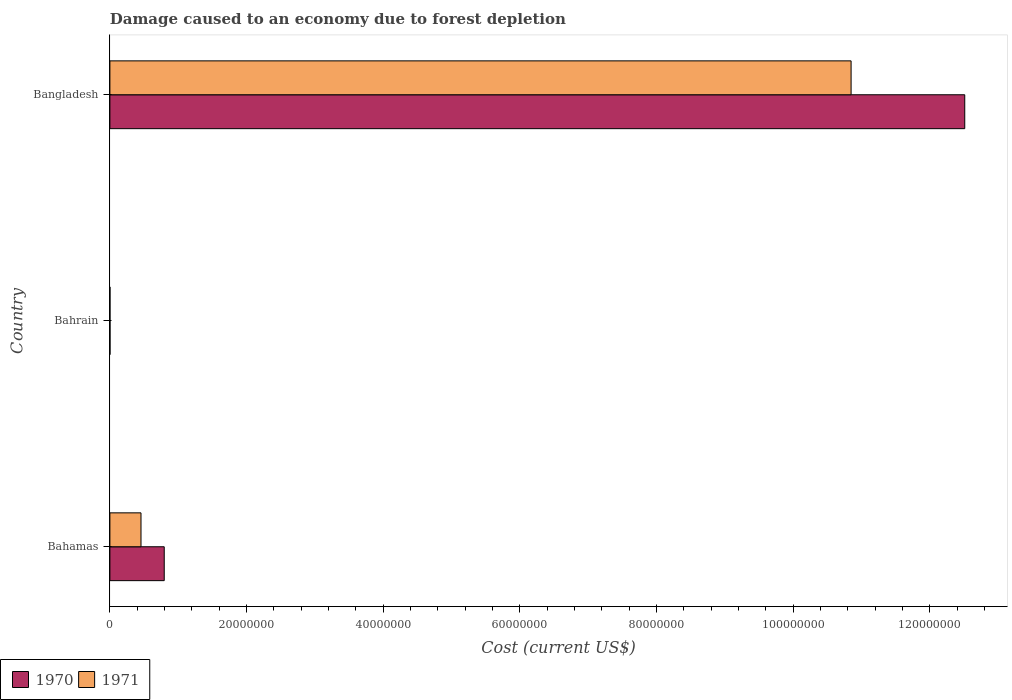What is the label of the 3rd group of bars from the top?
Make the answer very short. Bahamas. In how many cases, is the number of bars for a given country not equal to the number of legend labels?
Make the answer very short. 0. What is the cost of damage caused due to forest depletion in 1971 in Bangladesh?
Offer a very short reply. 1.08e+08. Across all countries, what is the maximum cost of damage caused due to forest depletion in 1971?
Provide a short and direct response. 1.08e+08. Across all countries, what is the minimum cost of damage caused due to forest depletion in 1971?
Offer a terse response. 1.16e+04. In which country was the cost of damage caused due to forest depletion in 1971 minimum?
Your answer should be very brief. Bahrain. What is the total cost of damage caused due to forest depletion in 1970 in the graph?
Offer a terse response. 1.33e+08. What is the difference between the cost of damage caused due to forest depletion in 1970 in Bahamas and that in Bangladesh?
Your answer should be compact. -1.17e+08. What is the difference between the cost of damage caused due to forest depletion in 1971 in Bahamas and the cost of damage caused due to forest depletion in 1970 in Bahrain?
Offer a terse response. 4.54e+06. What is the average cost of damage caused due to forest depletion in 1970 per country?
Ensure brevity in your answer.  4.44e+07. What is the difference between the cost of damage caused due to forest depletion in 1971 and cost of damage caused due to forest depletion in 1970 in Bahamas?
Your answer should be compact. -3.40e+06. What is the ratio of the cost of damage caused due to forest depletion in 1971 in Bahamas to that in Bahrain?
Make the answer very short. 391.63. Is the cost of damage caused due to forest depletion in 1970 in Bahrain less than that in Bangladesh?
Provide a succinct answer. Yes. What is the difference between the highest and the second highest cost of damage caused due to forest depletion in 1970?
Ensure brevity in your answer.  1.17e+08. What is the difference between the highest and the lowest cost of damage caused due to forest depletion in 1971?
Provide a succinct answer. 1.08e+08. In how many countries, is the cost of damage caused due to forest depletion in 1970 greater than the average cost of damage caused due to forest depletion in 1970 taken over all countries?
Your answer should be very brief. 1. How many bars are there?
Ensure brevity in your answer.  6. Does the graph contain grids?
Provide a succinct answer. No. What is the title of the graph?
Offer a terse response. Damage caused to an economy due to forest depletion. What is the label or title of the X-axis?
Your answer should be very brief. Cost (current US$). What is the Cost (current US$) of 1970 in Bahamas?
Offer a very short reply. 7.95e+06. What is the Cost (current US$) in 1971 in Bahamas?
Your answer should be very brief. 4.55e+06. What is the Cost (current US$) in 1970 in Bahrain?
Your response must be concise. 1.53e+04. What is the Cost (current US$) of 1971 in Bahrain?
Your response must be concise. 1.16e+04. What is the Cost (current US$) of 1970 in Bangladesh?
Provide a short and direct response. 1.25e+08. What is the Cost (current US$) in 1971 in Bangladesh?
Offer a very short reply. 1.08e+08. Across all countries, what is the maximum Cost (current US$) of 1970?
Offer a very short reply. 1.25e+08. Across all countries, what is the maximum Cost (current US$) in 1971?
Your answer should be very brief. 1.08e+08. Across all countries, what is the minimum Cost (current US$) in 1970?
Your response must be concise. 1.53e+04. Across all countries, what is the minimum Cost (current US$) of 1971?
Ensure brevity in your answer.  1.16e+04. What is the total Cost (current US$) in 1970 in the graph?
Provide a succinct answer. 1.33e+08. What is the total Cost (current US$) of 1971 in the graph?
Ensure brevity in your answer.  1.13e+08. What is the difference between the Cost (current US$) of 1970 in Bahamas and that in Bahrain?
Make the answer very short. 7.94e+06. What is the difference between the Cost (current US$) of 1971 in Bahamas and that in Bahrain?
Ensure brevity in your answer.  4.54e+06. What is the difference between the Cost (current US$) in 1970 in Bahamas and that in Bangladesh?
Your response must be concise. -1.17e+08. What is the difference between the Cost (current US$) in 1971 in Bahamas and that in Bangladesh?
Your answer should be very brief. -1.04e+08. What is the difference between the Cost (current US$) in 1970 in Bahrain and that in Bangladesh?
Your answer should be very brief. -1.25e+08. What is the difference between the Cost (current US$) in 1971 in Bahrain and that in Bangladesh?
Your answer should be very brief. -1.08e+08. What is the difference between the Cost (current US$) of 1970 in Bahamas and the Cost (current US$) of 1971 in Bahrain?
Keep it short and to the point. 7.94e+06. What is the difference between the Cost (current US$) of 1970 in Bahamas and the Cost (current US$) of 1971 in Bangladesh?
Your answer should be compact. -1.01e+08. What is the difference between the Cost (current US$) of 1970 in Bahrain and the Cost (current US$) of 1971 in Bangladesh?
Your answer should be compact. -1.08e+08. What is the average Cost (current US$) in 1970 per country?
Your answer should be compact. 4.44e+07. What is the average Cost (current US$) of 1971 per country?
Offer a terse response. 3.77e+07. What is the difference between the Cost (current US$) of 1970 and Cost (current US$) of 1971 in Bahamas?
Give a very brief answer. 3.40e+06. What is the difference between the Cost (current US$) of 1970 and Cost (current US$) of 1971 in Bahrain?
Make the answer very short. 3638.2. What is the difference between the Cost (current US$) in 1970 and Cost (current US$) in 1971 in Bangladesh?
Make the answer very short. 1.66e+07. What is the ratio of the Cost (current US$) of 1970 in Bahamas to that in Bahrain?
Provide a succinct answer. 520.98. What is the ratio of the Cost (current US$) in 1971 in Bahamas to that in Bahrain?
Make the answer very short. 391.63. What is the ratio of the Cost (current US$) of 1970 in Bahamas to that in Bangladesh?
Ensure brevity in your answer.  0.06. What is the ratio of the Cost (current US$) in 1971 in Bahamas to that in Bangladesh?
Keep it short and to the point. 0.04. What is the difference between the highest and the second highest Cost (current US$) of 1970?
Make the answer very short. 1.17e+08. What is the difference between the highest and the second highest Cost (current US$) in 1971?
Give a very brief answer. 1.04e+08. What is the difference between the highest and the lowest Cost (current US$) in 1970?
Your response must be concise. 1.25e+08. What is the difference between the highest and the lowest Cost (current US$) in 1971?
Ensure brevity in your answer.  1.08e+08. 